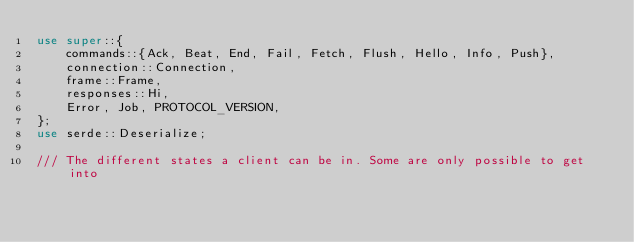Convert code to text. <code><loc_0><loc_0><loc_500><loc_500><_Rust_>use super::{
    commands::{Ack, Beat, End, Fail, Fetch, Flush, Hello, Info, Push},
    connection::Connection,
    frame::Frame,
    responses::Hi,
    Error, Job, PROTOCOL_VERSION,
};
use serde::Deserialize;

/// The different states a client can be in. Some are only possible to get into</code> 